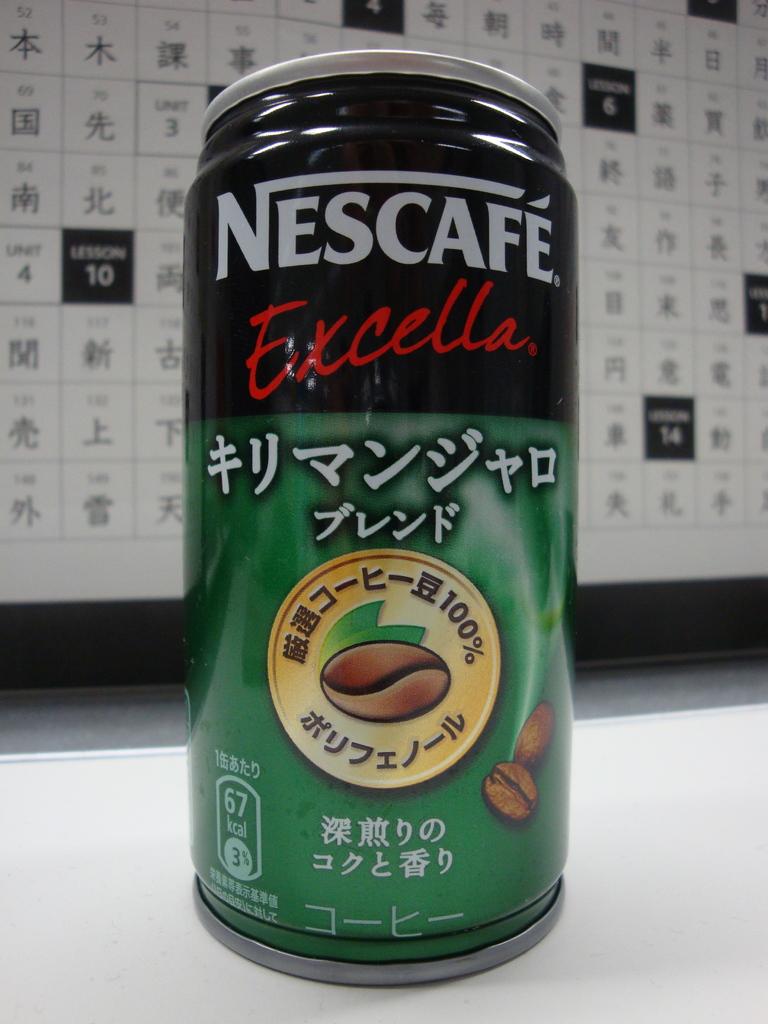What does it say under the brand?
Your response must be concise. Excella. 